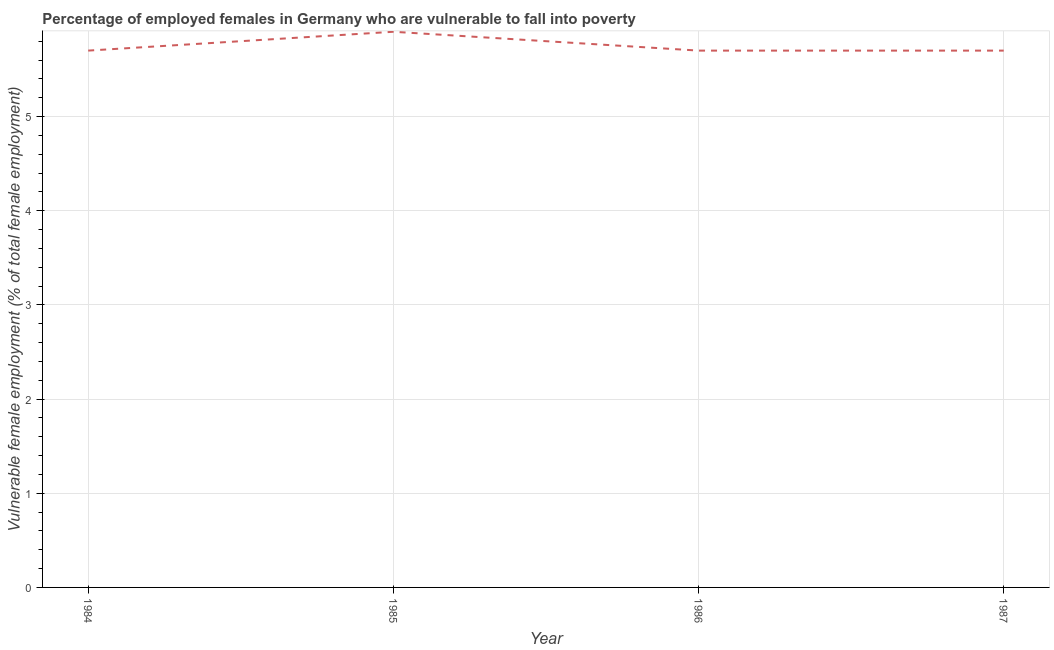What is the percentage of employed females who are vulnerable to fall into poverty in 1986?
Ensure brevity in your answer.  5.7. Across all years, what is the maximum percentage of employed females who are vulnerable to fall into poverty?
Provide a short and direct response. 5.9. Across all years, what is the minimum percentage of employed females who are vulnerable to fall into poverty?
Your answer should be very brief. 5.7. What is the sum of the percentage of employed females who are vulnerable to fall into poverty?
Your answer should be very brief. 23. What is the difference between the percentage of employed females who are vulnerable to fall into poverty in 1984 and 1986?
Provide a short and direct response. 0. What is the average percentage of employed females who are vulnerable to fall into poverty per year?
Offer a terse response. 5.75. What is the median percentage of employed females who are vulnerable to fall into poverty?
Offer a very short reply. 5.7. In how many years, is the percentage of employed females who are vulnerable to fall into poverty greater than 1.6 %?
Provide a short and direct response. 4. Do a majority of the years between 1986 and 1985 (inclusive) have percentage of employed females who are vulnerable to fall into poverty greater than 4.8 %?
Keep it short and to the point. No. What is the ratio of the percentage of employed females who are vulnerable to fall into poverty in 1985 to that in 1986?
Ensure brevity in your answer.  1.04. Is the percentage of employed females who are vulnerable to fall into poverty in 1986 less than that in 1987?
Your answer should be compact. No. Is the difference between the percentage of employed females who are vulnerable to fall into poverty in 1984 and 1986 greater than the difference between any two years?
Your answer should be compact. No. What is the difference between the highest and the second highest percentage of employed females who are vulnerable to fall into poverty?
Give a very brief answer. 0.2. What is the difference between the highest and the lowest percentage of employed females who are vulnerable to fall into poverty?
Keep it short and to the point. 0.2. In how many years, is the percentage of employed females who are vulnerable to fall into poverty greater than the average percentage of employed females who are vulnerable to fall into poverty taken over all years?
Your answer should be compact. 1. Does the percentage of employed females who are vulnerable to fall into poverty monotonically increase over the years?
Provide a succinct answer. No. How many lines are there?
Make the answer very short. 1. What is the difference between two consecutive major ticks on the Y-axis?
Your answer should be very brief. 1. Does the graph contain grids?
Provide a succinct answer. Yes. What is the title of the graph?
Offer a terse response. Percentage of employed females in Germany who are vulnerable to fall into poverty. What is the label or title of the X-axis?
Your answer should be very brief. Year. What is the label or title of the Y-axis?
Provide a short and direct response. Vulnerable female employment (% of total female employment). What is the Vulnerable female employment (% of total female employment) in 1984?
Your response must be concise. 5.7. What is the Vulnerable female employment (% of total female employment) of 1985?
Offer a very short reply. 5.9. What is the Vulnerable female employment (% of total female employment) in 1986?
Offer a terse response. 5.7. What is the Vulnerable female employment (% of total female employment) in 1987?
Provide a short and direct response. 5.7. What is the difference between the Vulnerable female employment (% of total female employment) in 1984 and 1985?
Your answer should be compact. -0.2. What is the difference between the Vulnerable female employment (% of total female employment) in 1985 and 1986?
Provide a succinct answer. 0.2. What is the difference between the Vulnerable female employment (% of total female employment) in 1985 and 1987?
Keep it short and to the point. 0.2. What is the ratio of the Vulnerable female employment (% of total female employment) in 1984 to that in 1986?
Provide a short and direct response. 1. What is the ratio of the Vulnerable female employment (% of total female employment) in 1985 to that in 1986?
Keep it short and to the point. 1.03. What is the ratio of the Vulnerable female employment (% of total female employment) in 1985 to that in 1987?
Ensure brevity in your answer.  1.03. 